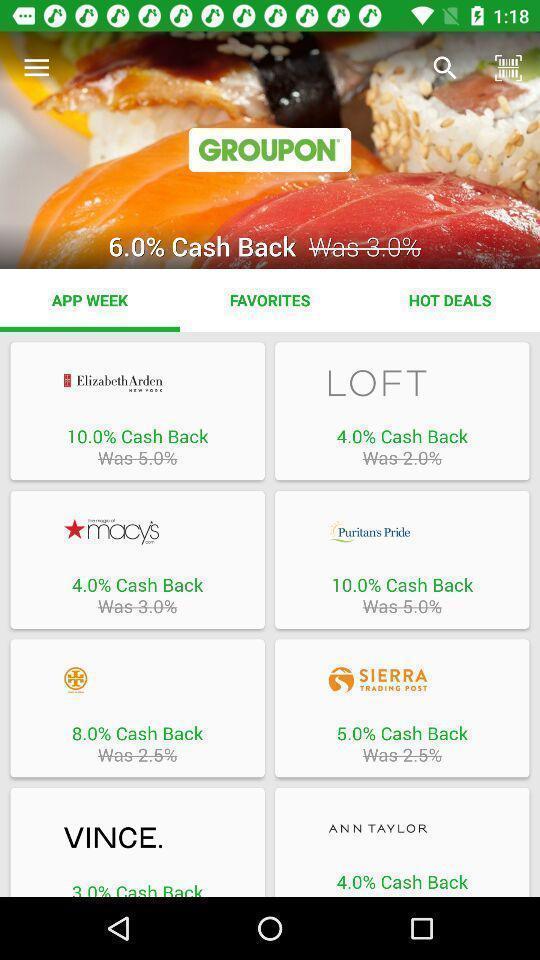Describe the content in this image. Screen displaying multiple brand names with cashback details. 